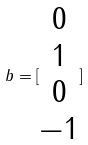Convert formula to latex. <formula><loc_0><loc_0><loc_500><loc_500>b = [ \begin{matrix} 0 \\ 1 \\ 0 \\ - 1 \end{matrix} ]</formula> 